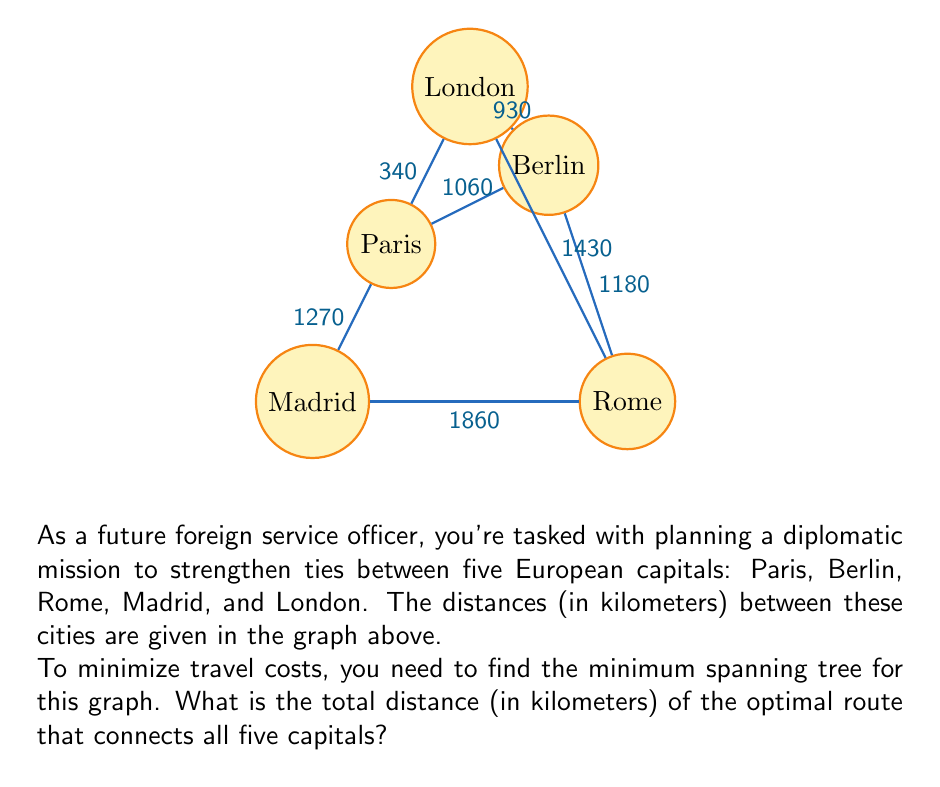Could you help me with this problem? To solve this problem, we'll use Kruskal's algorithm to find the minimum spanning tree:

1) First, sort all edges by weight (distance):
   Paris-London: 340 km
   London-Berlin: 930 km
   Paris-Berlin: 1060 km
   Rome-Berlin: 1180 km
   Madrid-Paris: 1270 km
   London-Rome: 1430 km
   Rome-Madrid: 1860 km

2) Start with the shortest edge: Paris-London (340 km)

3) Next shortest is London-Berlin (930 km). Add this to our tree.

4) Paris-Berlin (1060 km) would create a cycle, so skip it.

5) Rome-Berlin (1180 km) doesn't create a cycle, so add it.

6) Madrid-Paris (1270 km) doesn't create a cycle, so add it.

7) We now have a tree that connects all vertices, so we're done.

The minimum spanning tree consists of these edges:
- Paris-London: 340 km
- London-Berlin: 930 km
- Rome-Berlin: 1180 km
- Madrid-Paris: 1270 km

To get the total distance, we sum these lengths:

$$ 340 + 930 + 1180 + 1270 = 3720 \text{ km} $$

Therefore, the optimal route connecting all five capitals has a total distance of 3720 kilometers.
Answer: 3720 km 